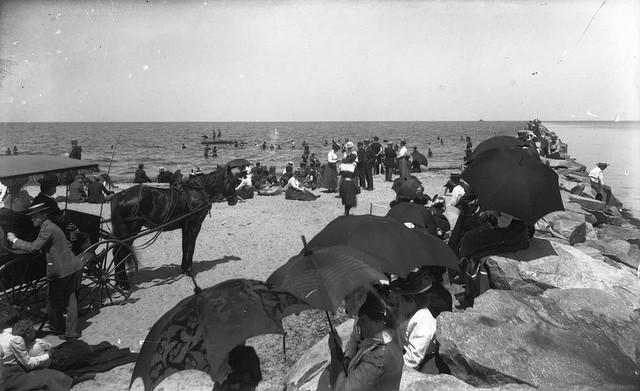How many people are there?
Give a very brief answer. 4. How many umbrellas are there?
Give a very brief answer. 4. 